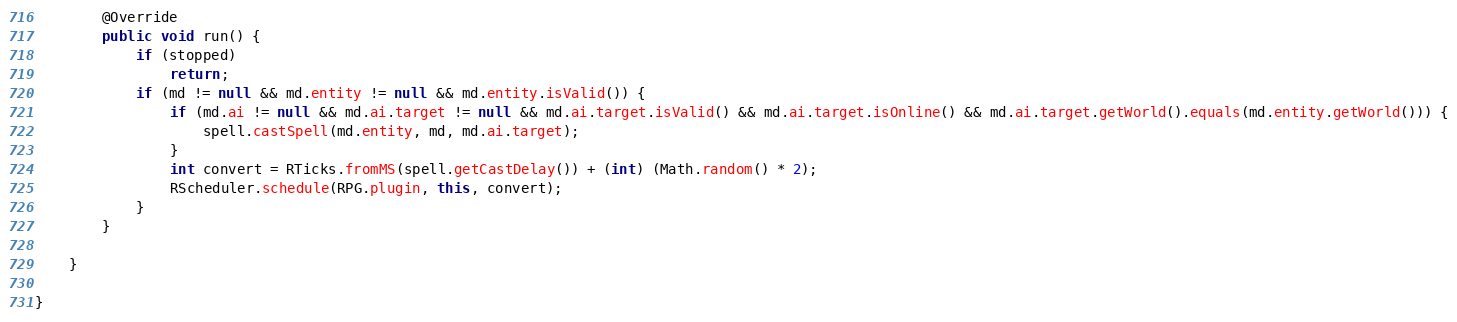Convert code to text. <code><loc_0><loc_0><loc_500><loc_500><_Java_>        @Override
        public void run() {
            if (stopped)
                return;
            if (md != null && md.entity != null && md.entity.isValid()) {
                if (md.ai != null && md.ai.target != null && md.ai.target.isValid() && md.ai.target.isOnline() && md.ai.target.getWorld().equals(md.entity.getWorld())) {
                    spell.castSpell(md.entity, md, md.ai.target);
                }
                int convert = RTicks.fromMS(spell.getCastDelay()) + (int) (Math.random() * 2);
                RScheduler.schedule(RPG.plugin, this, convert);
            }
        }

    }

}</code> 